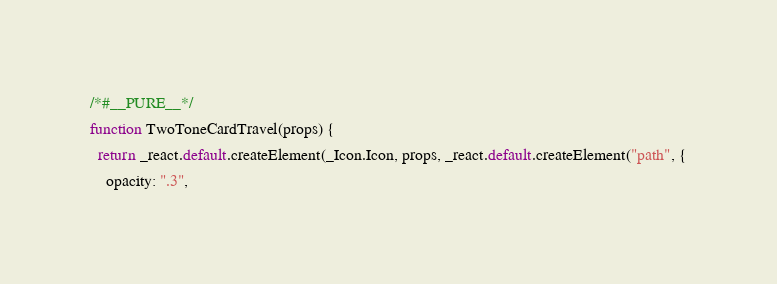<code> <loc_0><loc_0><loc_500><loc_500><_JavaScript_>/*#__PURE__*/
function TwoToneCardTravel(props) {
  return _react.default.createElement(_Icon.Icon, props, _react.default.createElement("path", {
    opacity: ".3",</code> 